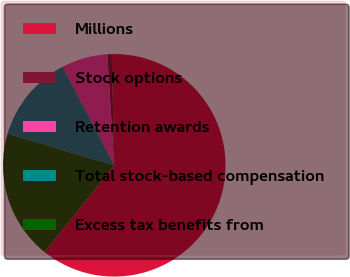Convert chart to OTSL. <chart><loc_0><loc_0><loc_500><loc_500><pie_chart><fcel>Millions<fcel>Stock options<fcel>Retention awards<fcel>Total stock-based compensation<fcel>Excess tax benefits from<nl><fcel>61.15%<fcel>0.64%<fcel>6.69%<fcel>12.74%<fcel>18.79%<nl></chart> 